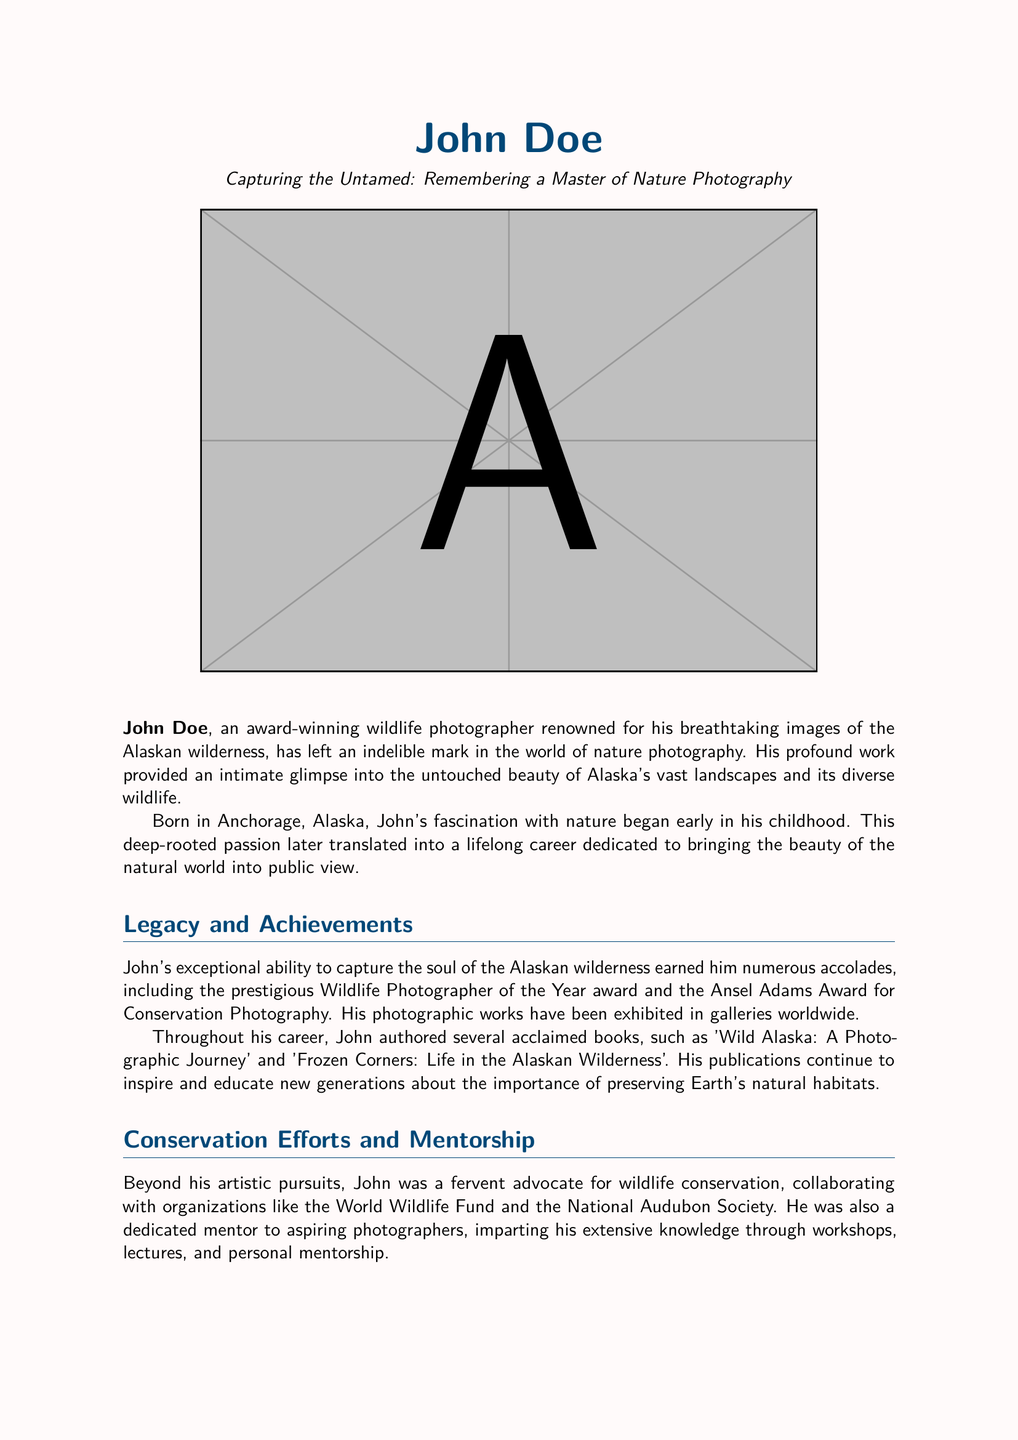What is the full name of the photographer? The document states the full name of the photographer as John Doe.
Answer: John Doe Where was John Doe born? The obituary mentions that John Doe was born in Anchorage, Alaska.
Answer: Anchorage, Alaska What prestigious award did John receive? The document notes that John received the Wildlife Photographer of the Year award.
Answer: Wildlife Photographer of the Year Name one book authored by John Doe. The obituary lists 'Wild Alaska: A Photographic Journey' as one of John's books.
Answer: Wild Alaska: A Photographic Journey Who did John collaborate with for conservation efforts? The document indicates that John collaborated with organizations like the World Wildlife Fund.
Answer: World Wildlife Fund How many children did John have? The document states that John is survived by two children, Emma and Jack.
Answer: Two What was John’s approach to mentoring? The obituary describes that John imparted knowledge through workshops and personal mentorship.
Answer: Workshops and personal mentorship What kind of spirit was John known for? The document describes John as having a gentle spirit.
Answer: Gentle spirit Which association awarded John the Ansel Adams Award? The obituary mentions that John received the Ansel Adams Award for Conservation Photography.
Answer: Ansel Adams Award for Conservation Photography 